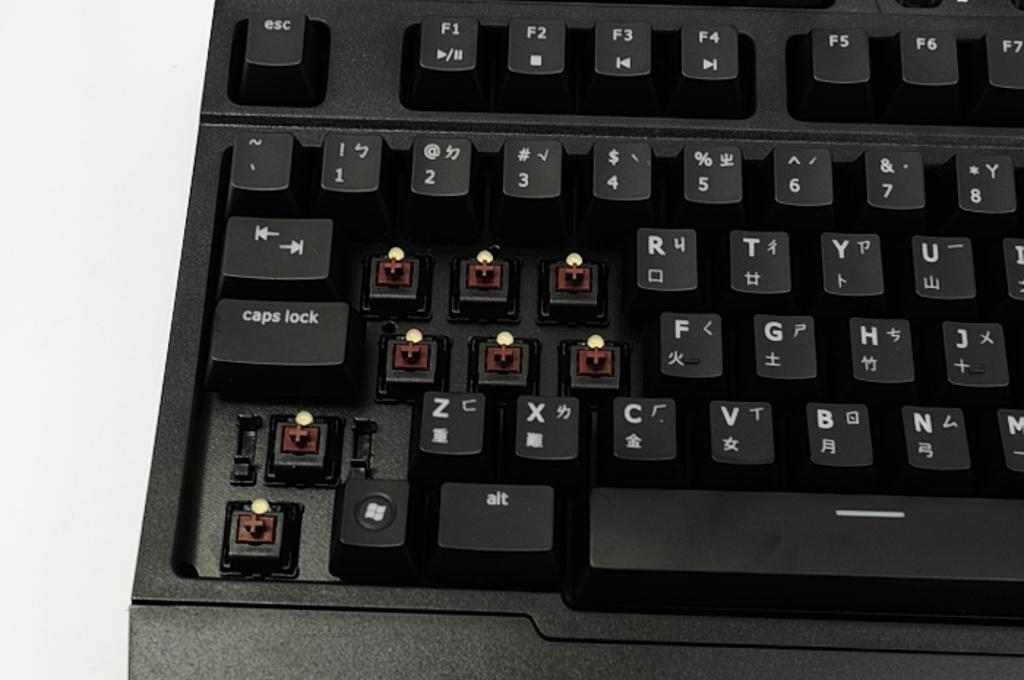<image>
Create a compact narrative representing the image presented. Black keyboard that has the symbol "+" on the bottom left. 